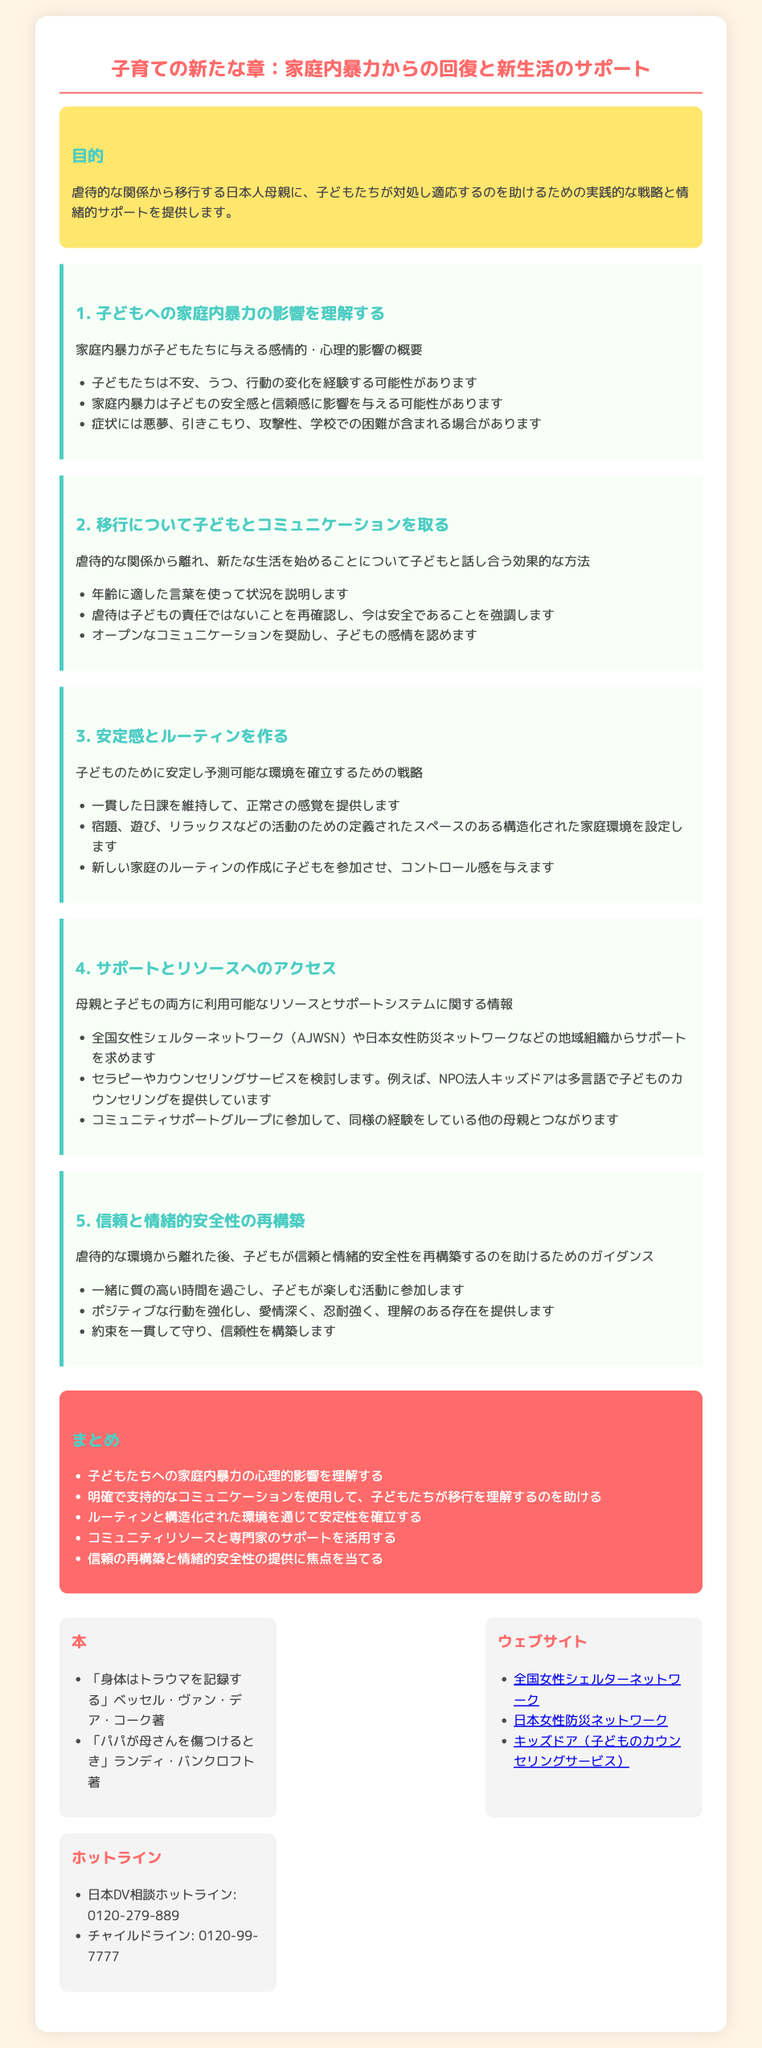目的は何ですか？ 目的は、虐待的な関係から移行する日本人母親に、子どもたちが対処し適応するのを助けるための実践的な戦略と情緒的サポートを提供することです。
Answer: 子どもたちが対処し適応するのを助ける 家庭内暴力が子どもに与える影響は何ですか？ 子どもたちが経験する可能性のある影響には、不安、うつ、行動の変化があります。
Answer: 不安、うつ、行動の変化 「信頼と情緒的安全性の再構築」で提案されている方法の一つは何ですか？ 子どもが信頼と情緒的安全性を再構築するための方法として、一緒に質の高い時間を過ごすことが挙げられています。
Answer: 一緒に質の高い時間を過ごす 子どもとのコミュニケーションで強調すべきことは何ですか？ 虐待は子どもの責任ではないことを再確認し、今は安全であることを強調することが大切です。
Answer: 子どもの責任ではないことを再確認 全国女性シェルターネットワークのウェブサイトはどこですか？ 微信ページ情報に基づいて、全国女性シェルターネットワークのウェブサイトは「http://www.ajwsn.org」です。
Answer: http://www.ajwsn.org 移行について子どもと話す際にどのような言葉を使うべきですか？ 年齢に適した言葉を使って、状況を説明することが推奨されています。
Answer: 年齢に適した言葉 